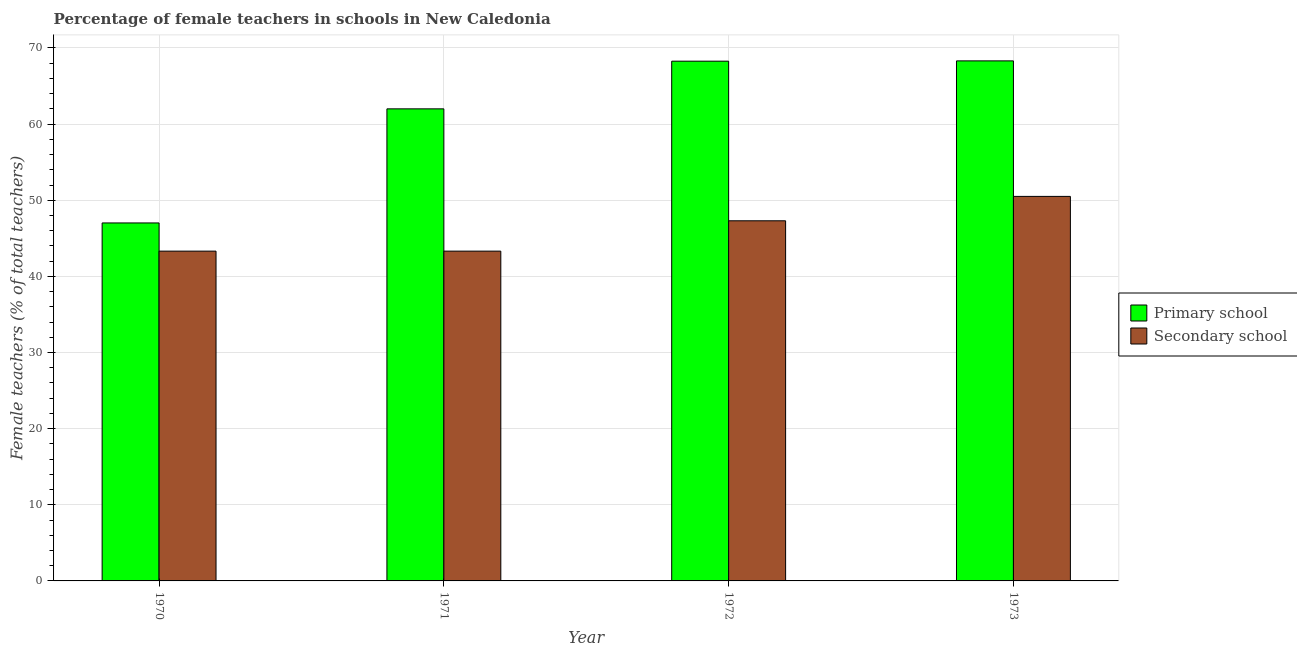How many different coloured bars are there?
Offer a terse response. 2. How many groups of bars are there?
Provide a succinct answer. 4. Are the number of bars per tick equal to the number of legend labels?
Give a very brief answer. Yes. What is the percentage of female teachers in primary schools in 1971?
Provide a succinct answer. 62.01. Across all years, what is the maximum percentage of female teachers in primary schools?
Your answer should be very brief. 68.31. Across all years, what is the minimum percentage of female teachers in secondary schools?
Ensure brevity in your answer.  43.32. In which year was the percentage of female teachers in secondary schools minimum?
Your answer should be compact. 1970. What is the total percentage of female teachers in primary schools in the graph?
Your response must be concise. 245.6. What is the difference between the percentage of female teachers in primary schools in 1970 and that in 1973?
Offer a terse response. -21.29. What is the difference between the percentage of female teachers in secondary schools in 1970 and the percentage of female teachers in primary schools in 1973?
Your answer should be compact. -7.19. What is the average percentage of female teachers in secondary schools per year?
Keep it short and to the point. 46.11. In how many years, is the percentage of female teachers in secondary schools greater than 10 %?
Provide a succinct answer. 4. What is the ratio of the percentage of female teachers in secondary schools in 1970 to that in 1972?
Make the answer very short. 0.92. What is the difference between the highest and the second highest percentage of female teachers in primary schools?
Offer a very short reply. 0.04. What is the difference between the highest and the lowest percentage of female teachers in primary schools?
Keep it short and to the point. 21.29. What does the 1st bar from the left in 1970 represents?
Ensure brevity in your answer.  Primary school. What does the 2nd bar from the right in 1970 represents?
Make the answer very short. Primary school. Are all the bars in the graph horizontal?
Give a very brief answer. No. How many years are there in the graph?
Your answer should be very brief. 4. What is the difference between two consecutive major ticks on the Y-axis?
Offer a very short reply. 10. Does the graph contain any zero values?
Make the answer very short. No. Does the graph contain grids?
Give a very brief answer. Yes. Where does the legend appear in the graph?
Provide a short and direct response. Center right. How many legend labels are there?
Keep it short and to the point. 2. How are the legend labels stacked?
Your answer should be compact. Vertical. What is the title of the graph?
Provide a short and direct response. Percentage of female teachers in schools in New Caledonia. What is the label or title of the Y-axis?
Keep it short and to the point. Female teachers (% of total teachers). What is the Female teachers (% of total teachers) in Primary school in 1970?
Ensure brevity in your answer.  47.02. What is the Female teachers (% of total teachers) in Secondary school in 1970?
Your answer should be very brief. 43.32. What is the Female teachers (% of total teachers) in Primary school in 1971?
Offer a terse response. 62.01. What is the Female teachers (% of total teachers) of Secondary school in 1971?
Keep it short and to the point. 43.32. What is the Female teachers (% of total teachers) of Primary school in 1972?
Provide a succinct answer. 68.27. What is the Female teachers (% of total teachers) of Secondary school in 1972?
Ensure brevity in your answer.  47.3. What is the Female teachers (% of total teachers) of Primary school in 1973?
Offer a terse response. 68.31. What is the Female teachers (% of total teachers) in Secondary school in 1973?
Provide a short and direct response. 50.51. Across all years, what is the maximum Female teachers (% of total teachers) in Primary school?
Provide a succinct answer. 68.31. Across all years, what is the maximum Female teachers (% of total teachers) in Secondary school?
Your response must be concise. 50.51. Across all years, what is the minimum Female teachers (% of total teachers) in Primary school?
Your answer should be compact. 47.02. Across all years, what is the minimum Female teachers (% of total teachers) of Secondary school?
Provide a short and direct response. 43.32. What is the total Female teachers (% of total teachers) in Primary school in the graph?
Give a very brief answer. 245.6. What is the total Female teachers (% of total teachers) of Secondary school in the graph?
Offer a very short reply. 184.44. What is the difference between the Female teachers (% of total teachers) in Primary school in 1970 and that in 1971?
Offer a terse response. -14.98. What is the difference between the Female teachers (% of total teachers) in Secondary school in 1970 and that in 1971?
Offer a very short reply. -0. What is the difference between the Female teachers (% of total teachers) in Primary school in 1970 and that in 1972?
Your answer should be very brief. -21.25. What is the difference between the Female teachers (% of total teachers) of Secondary school in 1970 and that in 1972?
Offer a very short reply. -3.99. What is the difference between the Female teachers (% of total teachers) of Primary school in 1970 and that in 1973?
Keep it short and to the point. -21.29. What is the difference between the Female teachers (% of total teachers) of Secondary school in 1970 and that in 1973?
Your answer should be very brief. -7.19. What is the difference between the Female teachers (% of total teachers) in Primary school in 1971 and that in 1972?
Provide a succinct answer. -6.26. What is the difference between the Female teachers (% of total teachers) of Secondary school in 1971 and that in 1972?
Ensure brevity in your answer.  -3.98. What is the difference between the Female teachers (% of total teachers) in Primary school in 1971 and that in 1973?
Give a very brief answer. -6.3. What is the difference between the Female teachers (% of total teachers) of Secondary school in 1971 and that in 1973?
Your answer should be compact. -7.19. What is the difference between the Female teachers (% of total teachers) of Primary school in 1972 and that in 1973?
Offer a very short reply. -0.04. What is the difference between the Female teachers (% of total teachers) in Secondary school in 1972 and that in 1973?
Provide a succinct answer. -3.2. What is the difference between the Female teachers (% of total teachers) of Primary school in 1970 and the Female teachers (% of total teachers) of Secondary school in 1971?
Provide a succinct answer. 3.7. What is the difference between the Female teachers (% of total teachers) in Primary school in 1970 and the Female teachers (% of total teachers) in Secondary school in 1972?
Your answer should be compact. -0.28. What is the difference between the Female teachers (% of total teachers) of Primary school in 1970 and the Female teachers (% of total teachers) of Secondary school in 1973?
Offer a terse response. -3.49. What is the difference between the Female teachers (% of total teachers) in Primary school in 1971 and the Female teachers (% of total teachers) in Secondary school in 1972?
Give a very brief answer. 14.7. What is the difference between the Female teachers (% of total teachers) of Primary school in 1971 and the Female teachers (% of total teachers) of Secondary school in 1973?
Ensure brevity in your answer.  11.5. What is the difference between the Female teachers (% of total teachers) of Primary school in 1972 and the Female teachers (% of total teachers) of Secondary school in 1973?
Your answer should be compact. 17.76. What is the average Female teachers (% of total teachers) in Primary school per year?
Offer a terse response. 61.4. What is the average Female teachers (% of total teachers) in Secondary school per year?
Make the answer very short. 46.11. In the year 1970, what is the difference between the Female teachers (% of total teachers) in Primary school and Female teachers (% of total teachers) in Secondary school?
Your answer should be very brief. 3.7. In the year 1971, what is the difference between the Female teachers (% of total teachers) of Primary school and Female teachers (% of total teachers) of Secondary school?
Provide a succinct answer. 18.69. In the year 1972, what is the difference between the Female teachers (% of total teachers) in Primary school and Female teachers (% of total teachers) in Secondary school?
Give a very brief answer. 20.97. In the year 1973, what is the difference between the Female teachers (% of total teachers) in Primary school and Female teachers (% of total teachers) in Secondary school?
Your answer should be very brief. 17.8. What is the ratio of the Female teachers (% of total teachers) in Primary school in 1970 to that in 1971?
Ensure brevity in your answer.  0.76. What is the ratio of the Female teachers (% of total teachers) in Secondary school in 1970 to that in 1971?
Your response must be concise. 1. What is the ratio of the Female teachers (% of total teachers) in Primary school in 1970 to that in 1972?
Keep it short and to the point. 0.69. What is the ratio of the Female teachers (% of total teachers) in Secondary school in 1970 to that in 1972?
Your answer should be very brief. 0.92. What is the ratio of the Female teachers (% of total teachers) of Primary school in 1970 to that in 1973?
Provide a short and direct response. 0.69. What is the ratio of the Female teachers (% of total teachers) of Secondary school in 1970 to that in 1973?
Provide a short and direct response. 0.86. What is the ratio of the Female teachers (% of total teachers) of Primary school in 1971 to that in 1972?
Your response must be concise. 0.91. What is the ratio of the Female teachers (% of total teachers) in Secondary school in 1971 to that in 1972?
Your response must be concise. 0.92. What is the ratio of the Female teachers (% of total teachers) of Primary school in 1971 to that in 1973?
Provide a short and direct response. 0.91. What is the ratio of the Female teachers (% of total teachers) in Secondary school in 1971 to that in 1973?
Make the answer very short. 0.86. What is the ratio of the Female teachers (% of total teachers) in Primary school in 1972 to that in 1973?
Make the answer very short. 1. What is the ratio of the Female teachers (% of total teachers) in Secondary school in 1972 to that in 1973?
Your answer should be very brief. 0.94. What is the difference between the highest and the second highest Female teachers (% of total teachers) of Primary school?
Offer a very short reply. 0.04. What is the difference between the highest and the second highest Female teachers (% of total teachers) of Secondary school?
Keep it short and to the point. 3.2. What is the difference between the highest and the lowest Female teachers (% of total teachers) of Primary school?
Ensure brevity in your answer.  21.29. What is the difference between the highest and the lowest Female teachers (% of total teachers) in Secondary school?
Keep it short and to the point. 7.19. 